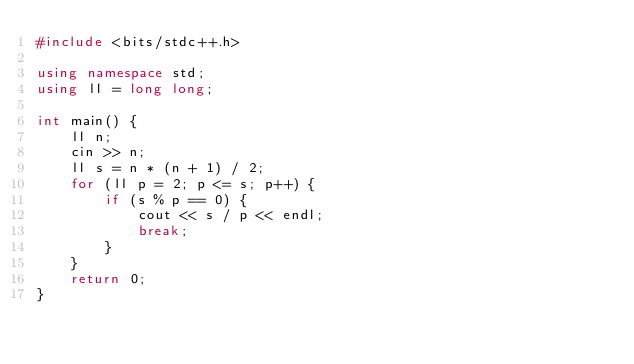Convert code to text. <code><loc_0><loc_0><loc_500><loc_500><_C++_>#include <bits/stdc++.h>

using namespace std;
using ll = long long;

int main() {
    ll n;
    cin >> n;
    ll s = n * (n + 1) / 2;
    for (ll p = 2; p <= s; p++) {
        if (s % p == 0) {
            cout << s / p << endl;
            break;
        }
    }
    return 0;
}</code> 